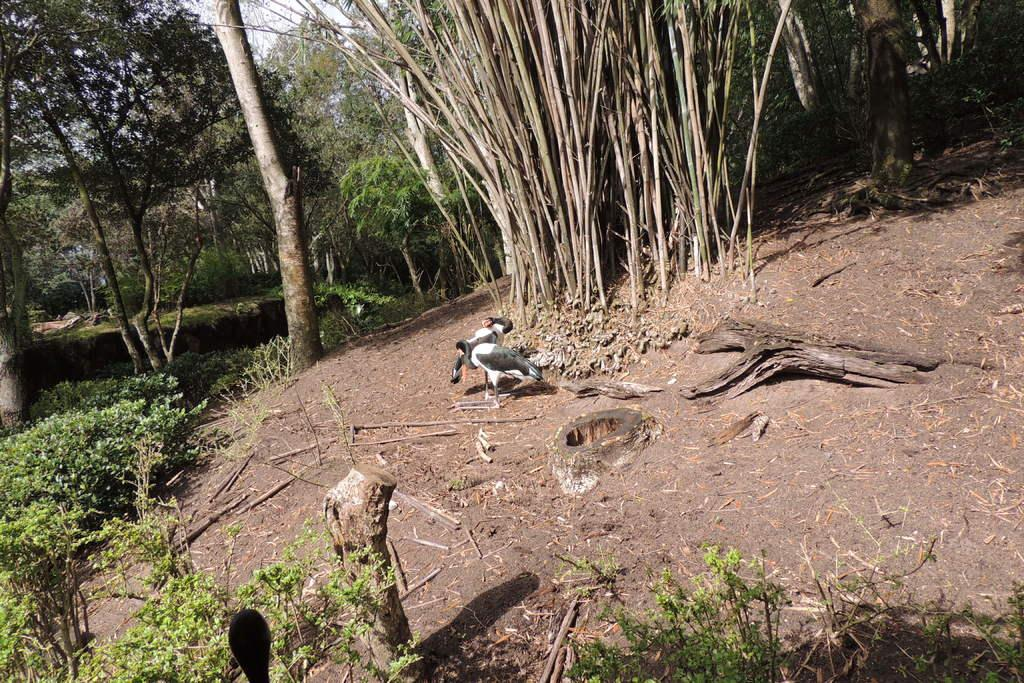How many birds are in the image? There are two birds in the image. What colors are the birds? One bird is white, and the other is gray. What can be seen in the background of the image? There are plants and trees in the background of the image. What color are the plants and trees? The plants and trees are green. What is visible in the sky in the background of the image? The sky is visible in the background of the image, and it is white. Where are the rabbits hiding in the image? There are no rabbits present in the image. What is the queen doing in the image? There is no queen present in the image. 